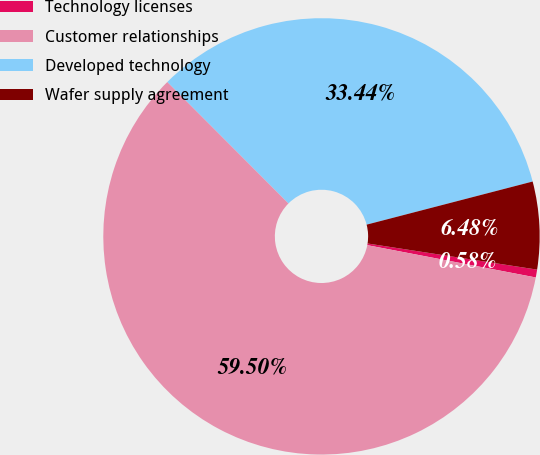Convert chart to OTSL. <chart><loc_0><loc_0><loc_500><loc_500><pie_chart><fcel>Technology licenses<fcel>Customer relationships<fcel>Developed technology<fcel>Wafer supply agreement<nl><fcel>0.58%<fcel>59.5%<fcel>33.44%<fcel>6.48%<nl></chart> 